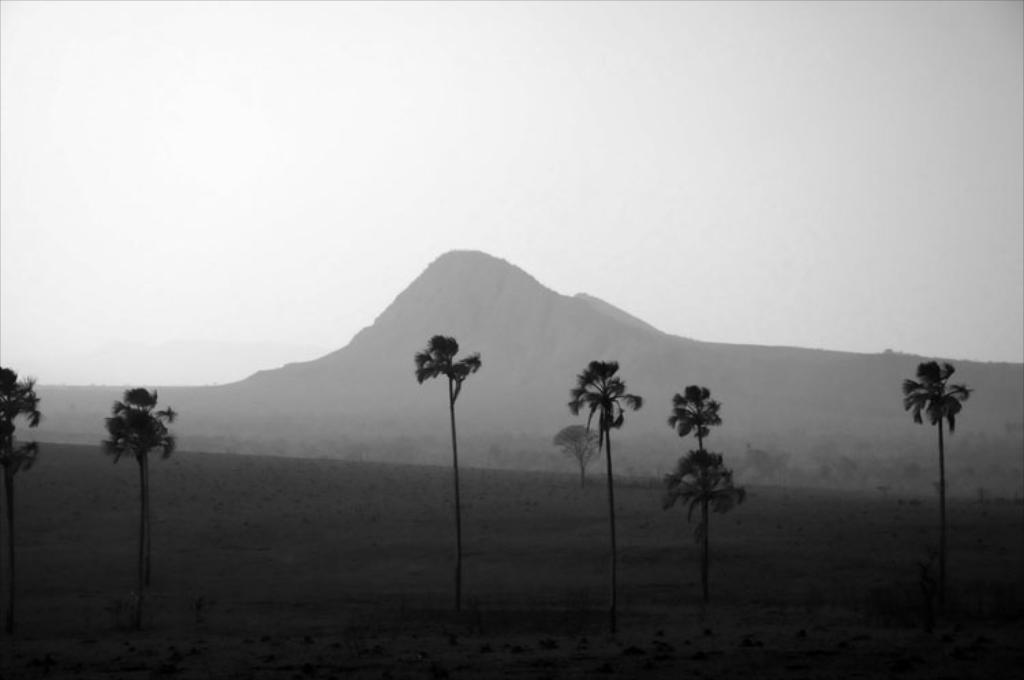What type of photograph is shown in the image? The photograph in the image is black and white. What is the subject of the photograph? The photograph depicts coconut trees. What can be seen in the background of the image? There is a huge mountain visible in the background of the image. What type of beef is being served on vacation in the image? There is no beef or vacation depicted in the image; it features a black and white photograph of coconut trees with a mountain in the background. How many nails are visible in the image? There are no nails present in the image. 